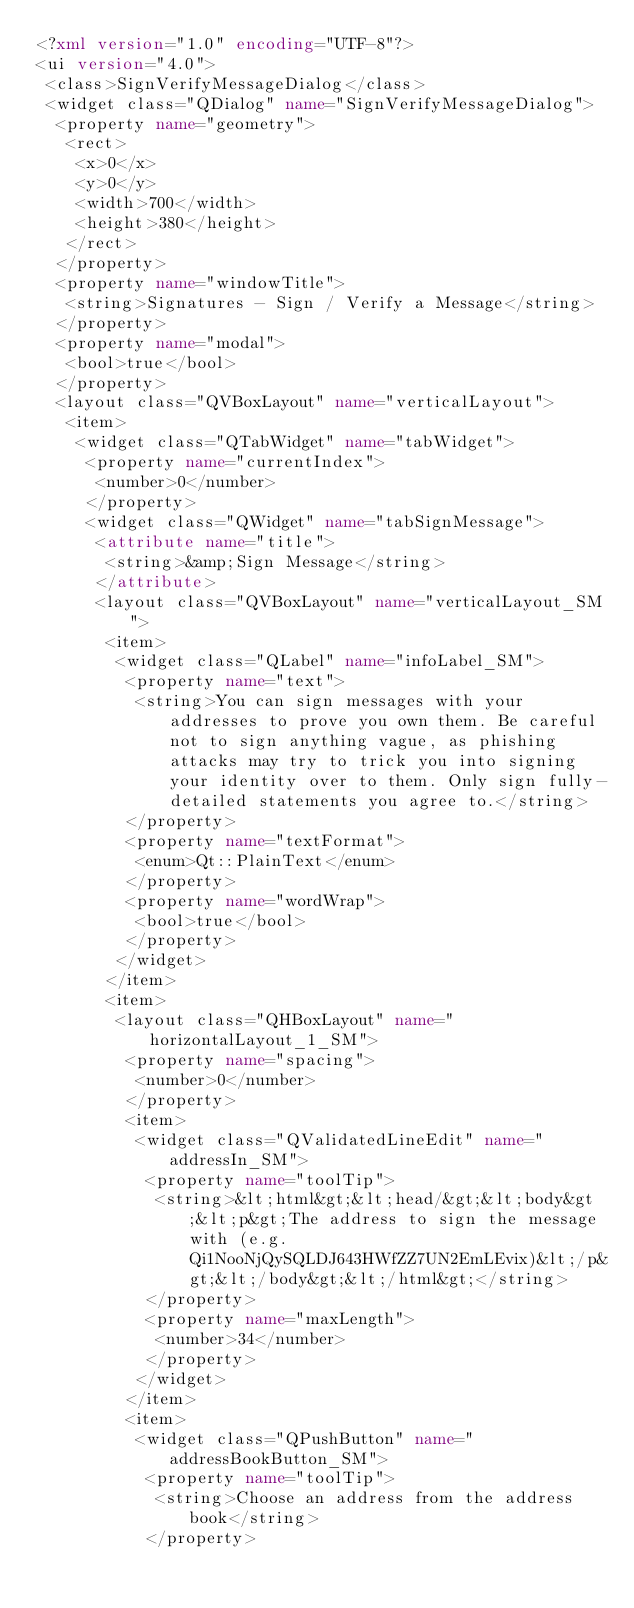Convert code to text. <code><loc_0><loc_0><loc_500><loc_500><_XML_><?xml version="1.0" encoding="UTF-8"?>
<ui version="4.0">
 <class>SignVerifyMessageDialog</class>
 <widget class="QDialog" name="SignVerifyMessageDialog">
  <property name="geometry">
   <rect>
    <x>0</x>
    <y>0</y>
    <width>700</width>
    <height>380</height>
   </rect>
  </property>
  <property name="windowTitle">
   <string>Signatures - Sign / Verify a Message</string>
  </property>
  <property name="modal">
   <bool>true</bool>
  </property>
  <layout class="QVBoxLayout" name="verticalLayout">
   <item>
    <widget class="QTabWidget" name="tabWidget">
     <property name="currentIndex">
      <number>0</number>
     </property>
     <widget class="QWidget" name="tabSignMessage">
      <attribute name="title">
       <string>&amp;Sign Message</string>
      </attribute>
      <layout class="QVBoxLayout" name="verticalLayout_SM">
       <item>
        <widget class="QLabel" name="infoLabel_SM">
         <property name="text">
          <string>You can sign messages with your addresses to prove you own them. Be careful not to sign anything vague, as phishing attacks may try to trick you into signing your identity over to them. Only sign fully-detailed statements you agree to.</string>
         </property>
         <property name="textFormat">
          <enum>Qt::PlainText</enum>
         </property>
         <property name="wordWrap">
          <bool>true</bool>
         </property>
        </widget>
       </item>
       <item>
        <layout class="QHBoxLayout" name="horizontalLayout_1_SM">
         <property name="spacing">
          <number>0</number>
         </property>
         <item>
          <widget class="QValidatedLineEdit" name="addressIn_SM">
           <property name="toolTip">
            <string>&lt;html&gt;&lt;head/&gt;&lt;body&gt;&lt;p&gt;The address to sign the message with (e.g. Qi1NooNjQySQLDJ643HWfZZ7UN2EmLEvix)&lt;/p&gt;&lt;/body&gt;&lt;/html&gt;</string>
           </property>
           <property name="maxLength">
            <number>34</number>
           </property>
          </widget>
         </item>
         <item>
          <widget class="QPushButton" name="addressBookButton_SM">
           <property name="toolTip">
            <string>Choose an address from the address book</string>
           </property></code> 